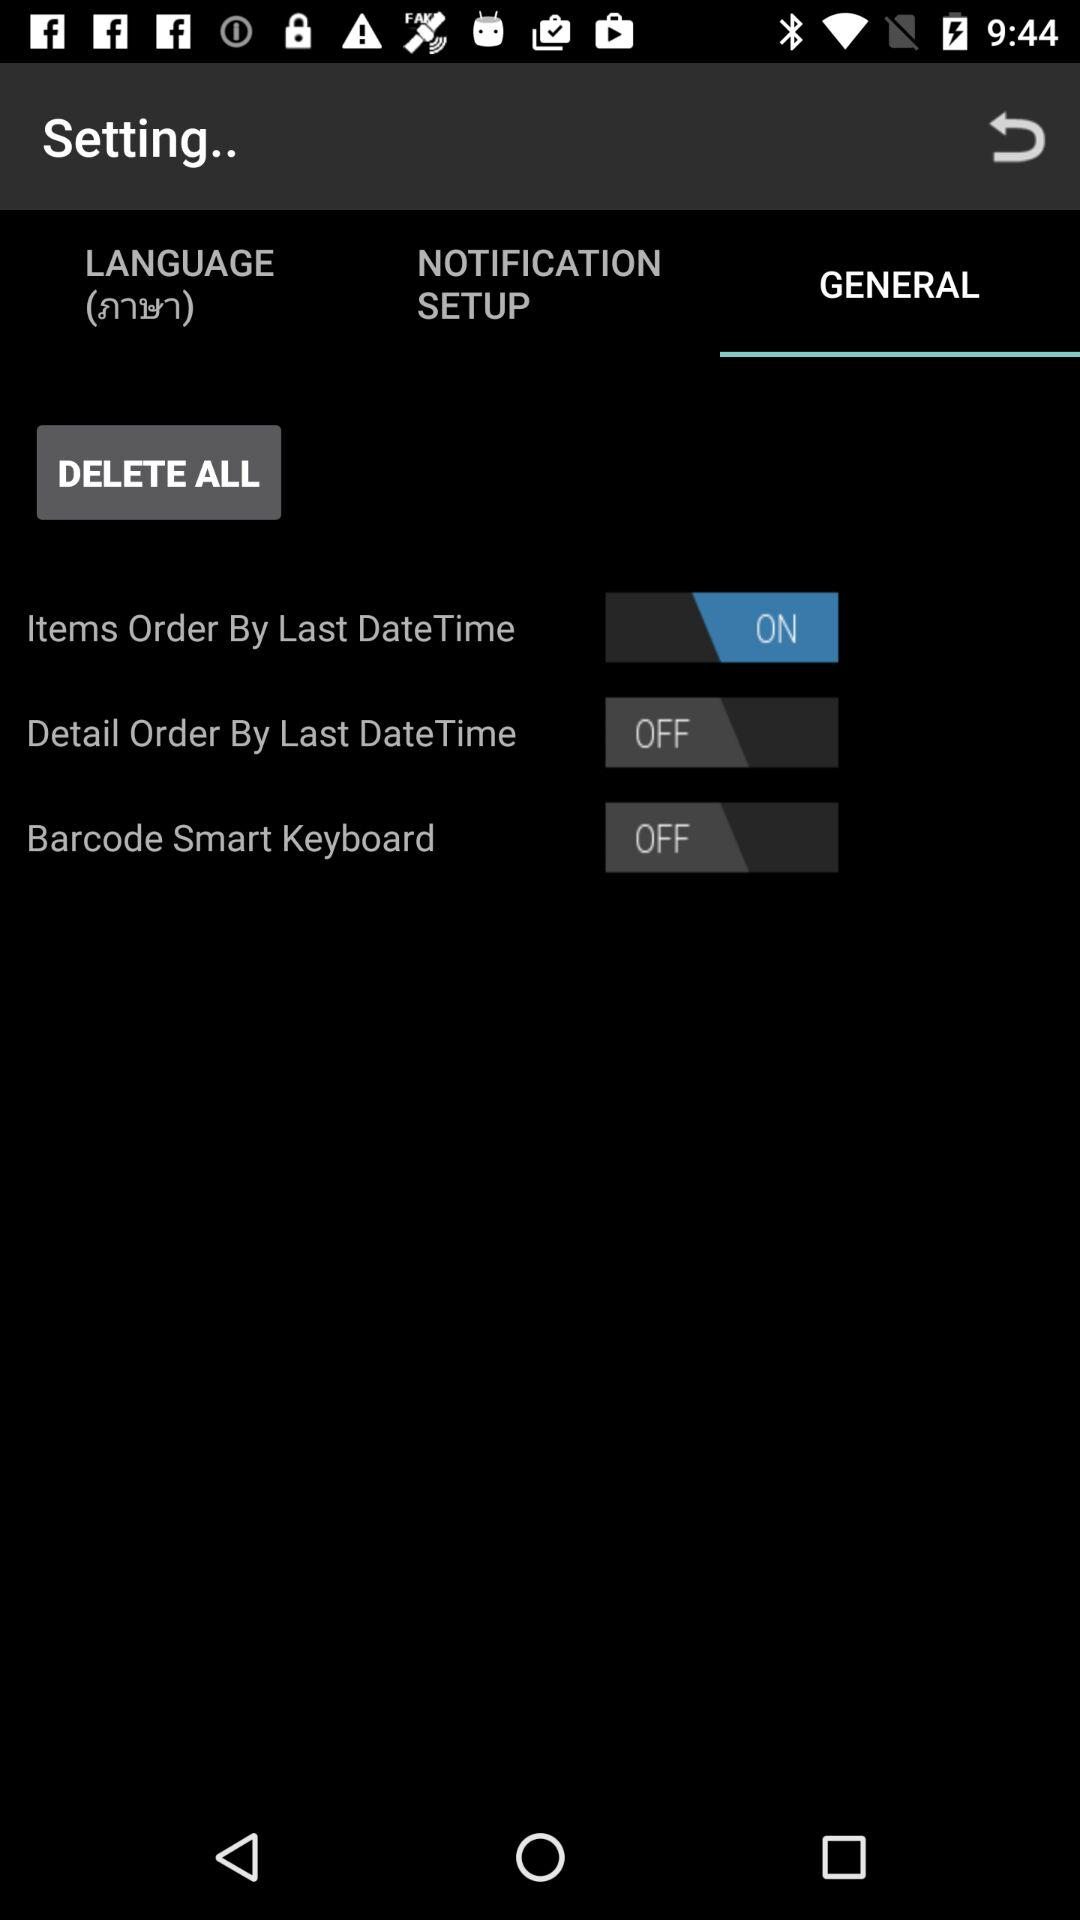Which tab is selected? The selected tab is "GENERAL". 